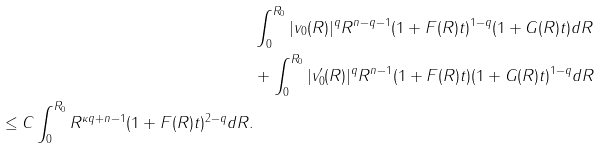<formula> <loc_0><loc_0><loc_500><loc_500>& \int _ { 0 } ^ { R _ { 0 } } | v _ { 0 } ( R ) | ^ { q } R ^ { n - q - 1 } ( 1 + F ( R ) t ) ^ { 1 - q } ( 1 + G ( R ) t ) d R \\ & + \int _ { 0 } ^ { R _ { 0 } } | v ^ { \prime } _ { 0 } ( R ) | ^ { q } R ^ { n - 1 } ( 1 + F ( R ) t ) ( 1 + G ( R ) t ) ^ { 1 - q } d R \\ \leq C \int _ { 0 } ^ { R _ { 0 } } R ^ { \kappa q + n - 1 } ( 1 + F ( R ) t ) ^ { 2 - q } d R .</formula> 